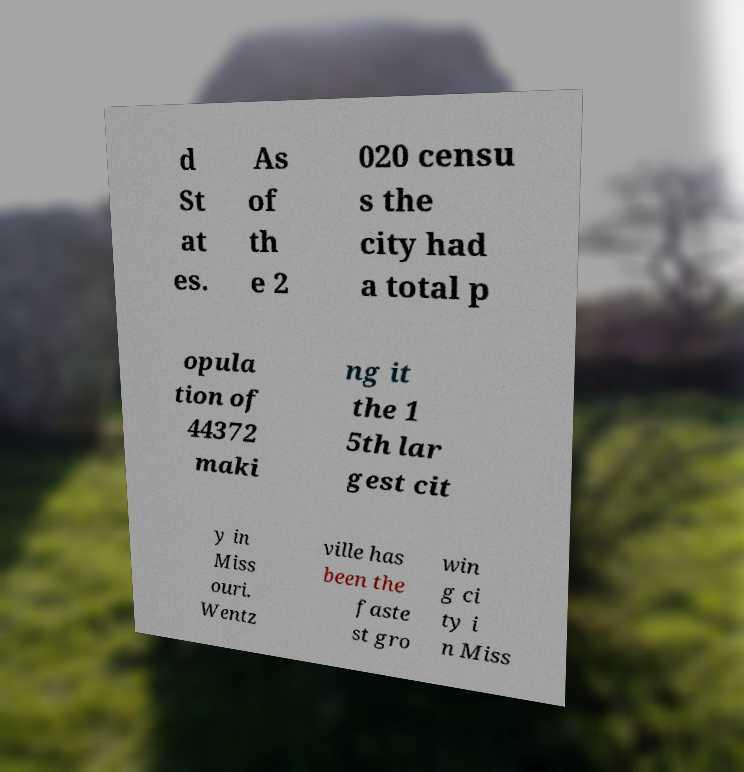What messages or text are displayed in this image? I need them in a readable, typed format. d St at es. As of th e 2 020 censu s the city had a total p opula tion of 44372 maki ng it the 1 5th lar gest cit y in Miss ouri. Wentz ville has been the faste st gro win g ci ty i n Miss 